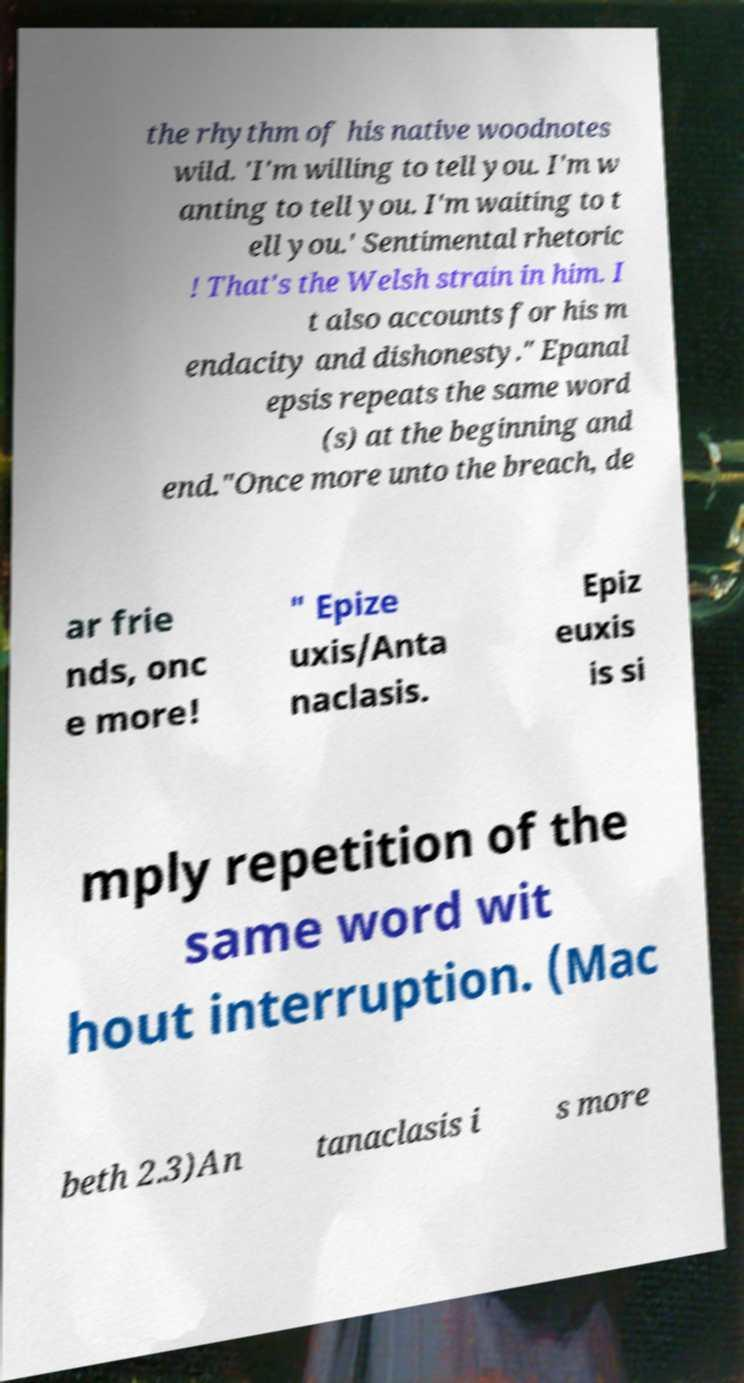Please identify and transcribe the text found in this image. the rhythm of his native woodnotes wild. 'I'm willing to tell you. I'm w anting to tell you. I'm waiting to t ell you.' Sentimental rhetoric ! That's the Welsh strain in him. I t also accounts for his m endacity and dishonesty." Epanal epsis repeats the same word (s) at the beginning and end."Once more unto the breach, de ar frie nds, onc e more! " Epize uxis/Anta naclasis. Epiz euxis is si mply repetition of the same word wit hout interruption. (Mac beth 2.3)An tanaclasis i s more 